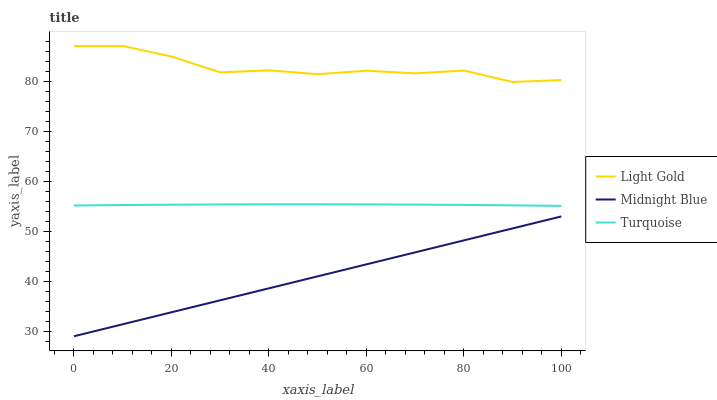Does Midnight Blue have the minimum area under the curve?
Answer yes or no. Yes. Does Light Gold have the maximum area under the curve?
Answer yes or no. Yes. Does Light Gold have the minimum area under the curve?
Answer yes or no. No. Does Midnight Blue have the maximum area under the curve?
Answer yes or no. No. Is Midnight Blue the smoothest?
Answer yes or no. Yes. Is Light Gold the roughest?
Answer yes or no. Yes. Is Light Gold the smoothest?
Answer yes or no. No. Is Midnight Blue the roughest?
Answer yes or no. No. Does Midnight Blue have the lowest value?
Answer yes or no. Yes. Does Light Gold have the lowest value?
Answer yes or no. No. Does Light Gold have the highest value?
Answer yes or no. Yes. Does Midnight Blue have the highest value?
Answer yes or no. No. Is Midnight Blue less than Turquoise?
Answer yes or no. Yes. Is Light Gold greater than Midnight Blue?
Answer yes or no. Yes. Does Midnight Blue intersect Turquoise?
Answer yes or no. No. 